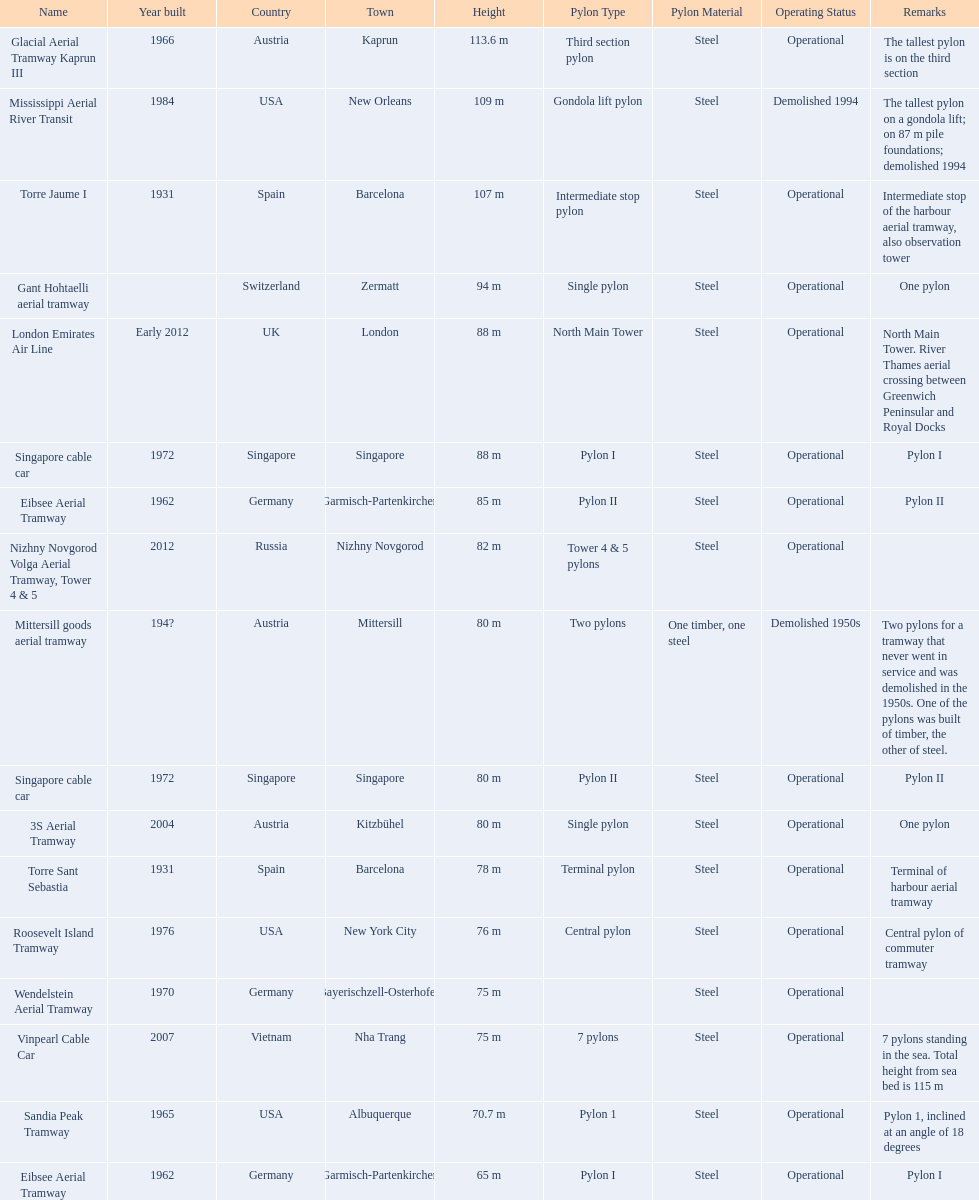How many metres is the tallest pylon? 113.6 m. 